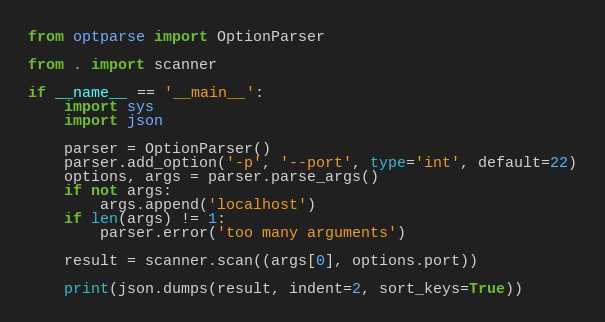<code> <loc_0><loc_0><loc_500><loc_500><_Python_>from optparse import OptionParser

from . import scanner

if __name__ == '__main__':
    import sys
    import json

    parser = OptionParser()
    parser.add_option('-p', '--port', type='int', default=22)
    options, args = parser.parse_args()
    if not args:
        args.append('localhost')
    if len(args) != 1:
        parser.error('too many arguments')

    result = scanner.scan((args[0], options.port))

    print(json.dumps(result, indent=2, sort_keys=True))
</code> 